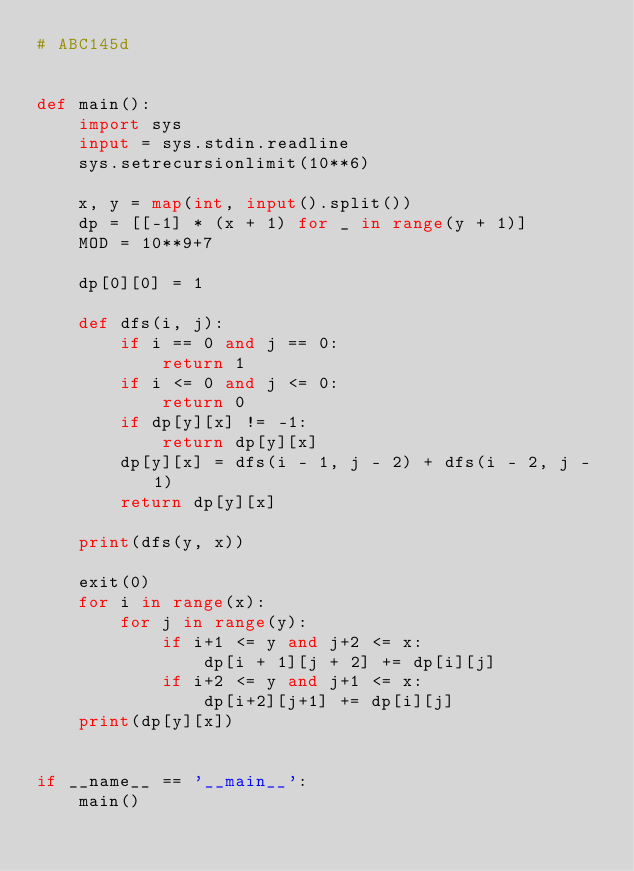Convert code to text. <code><loc_0><loc_0><loc_500><loc_500><_Python_># ABC145d


def main():
    import sys
    input = sys.stdin.readline
    sys.setrecursionlimit(10**6)

    x, y = map(int, input().split())
    dp = [[-1] * (x + 1) for _ in range(y + 1)]
    MOD = 10**9+7

    dp[0][0] = 1

    def dfs(i, j):
        if i == 0 and j == 0:
            return 1
        if i <= 0 and j <= 0:
            return 0
        if dp[y][x] != -1:
            return dp[y][x]
        dp[y][x] = dfs(i - 1, j - 2) + dfs(i - 2, j - 1)
        return dp[y][x]

    print(dfs(y, x))

    exit(0)
    for i in range(x):
        for j in range(y):
            if i+1 <= y and j+2 <= x:
                dp[i + 1][j + 2] += dp[i][j]
            if i+2 <= y and j+1 <= x:
                dp[i+2][j+1] += dp[i][j]
    print(dp[y][x])


if __name__ == '__main__':
    main()</code> 